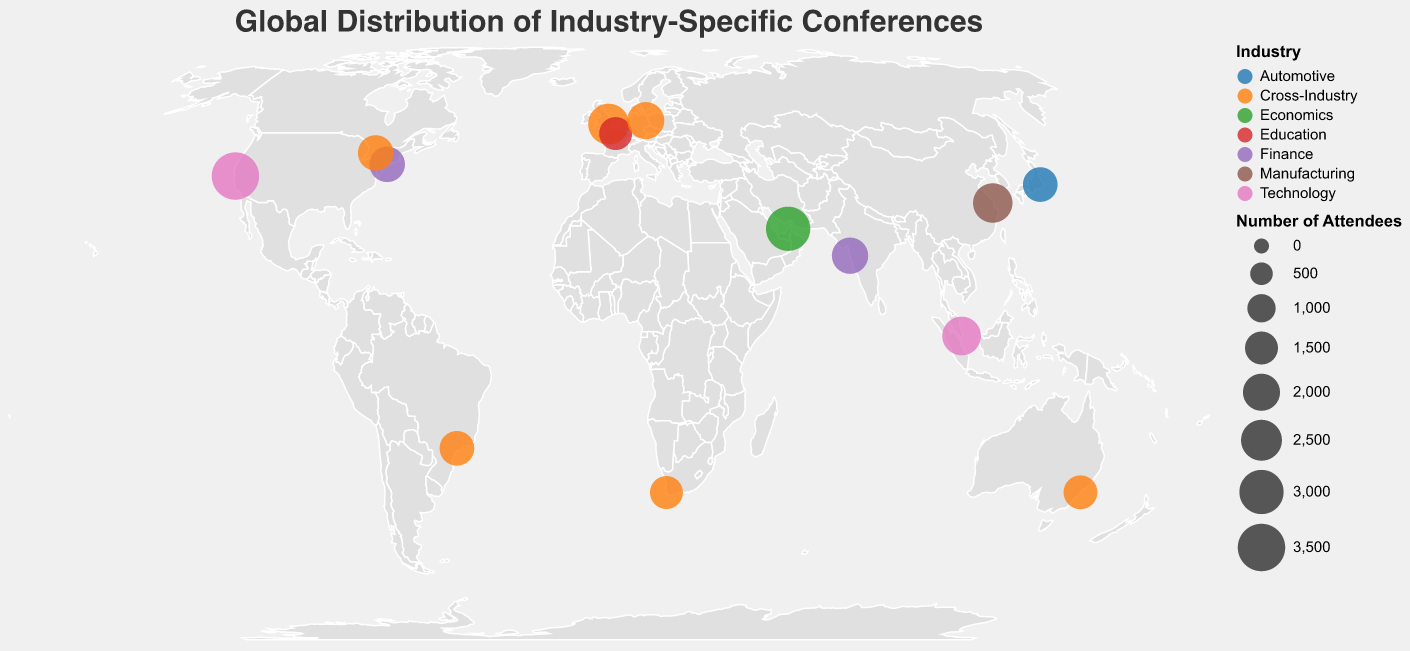Which conference has the highest number of attendees? By examining the sizes of the circles on the plot and noting which circle is the largest, the largest circle corresponds to TechCrunch Disrupt in San Francisco, which has the highest number of attendees.
Answer: TechCrunch Disrupt in San Francisco Which country hosts the most industry-specific conferences shown in the distribution? Observing the plot, the circles are marked according to their locations, and the USA has two circles, indicating it hosts two conferences: Fortune Global Forum in New York and TechCrunch Disrupt in San Francisco.
Answer: USA What is the total number of attendees for conferences in Finance? Two Finance conferences are shown: Fortune Global Forum in New York (1800 attendees) and Emerging Markets Business Forum in Mumbai (1900 attendees). Summing these values gives 1800 + 1900 = 3700.
Answer: 3700 How many conferences are categorized as Cross-Industry? Observing the colors and labels on the geographic plot, we can count the Cross-Industry conferences: Global CEO Summit in London, European Business Leaders Convention in Berlin, Asia-Pacific CEO Congress in Sydney, North American Leadership Symposium in Toronto, Latin American Executive Summit in São Paulo, and Africa CEO Forum in Cape Town. This totals to six conferences.
Answer: 6 Which conference represents the technology industry and has the largest number of attendees? By looking at the circles representing technology industry conferences and comparing their sizes, TechCrunch Disrupt in San Francisco has the largest number of attendees among technology conferences.
Answer: TechCrunch Disrupt in San Francisco Are there any conferences represented in South America? By checking the geographic plot for circles located in South America, we find one circle in São Paulo, Brazil, representing the Latin American Executive Summit.
Answer: Yes Which conference has the least number of attendees and in what industry is it categorized? Observing the size of the circles in the plot, the smallest circle corresponds to the INSEAD CEO Leadership Forum in Paris, which is categorized under Education, having the least number of attendees (1500).
Answer: INSEAD CEO Leadership Forum in Paris, Education What is the average number of attendees across all the conferences? Summing the total number of attendees from all conferences: 2500 (London) + 1800 (New York) + 2200 (Singapore) + 3000 (Dubai) + 1500 (Paris) + 1700 (Tokyo) + 3500 (San Francisco) + 2000 (Berlin) + 1600 (Sydney) + 2300 (Shanghai) + 1900 (Mumbai) + 1800 (Toronto) + 1700 (São Paulo) + 1500 (Cape Town) = 29000. There are 14 conferences, so the average is 29000 / 14 = 2071.4.
Answer: 2071.4 Which industry is represented by the most conferences on the map? By noting the color legend and counting the number of circles for each industry, Cross-Industry has the most conferences with six represented on the map.
Answer: Cross-Industry Which city in the Asia-Pacific region hosts the largest conference by attendee count? Identifying the cities in the Asia-Pacific region from the plot, and comparing the sizes of their circles, TechCrunch Disrupt in San Francisco (although not in Asia-Pacific), has the largest number, followed by Asia-Pacific Leadership Conference in Singapore having 2200 attendees.
Answer: Singapore 